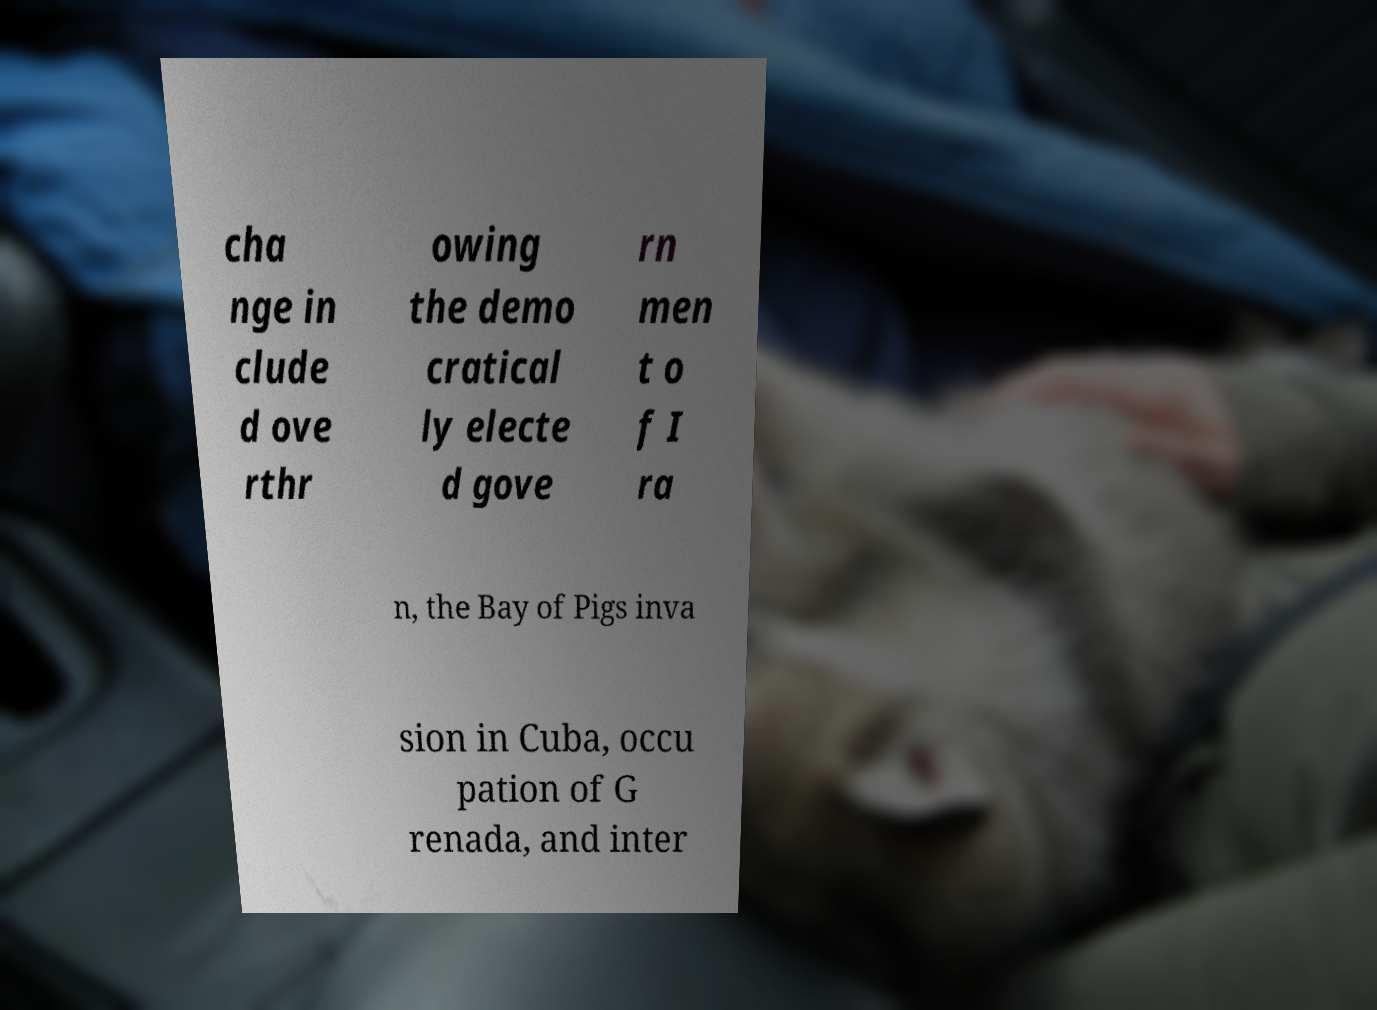Please identify and transcribe the text found in this image. cha nge in clude d ove rthr owing the demo cratical ly electe d gove rn men t o f I ra n, the Bay of Pigs inva sion in Cuba, occu pation of G renada, and inter 